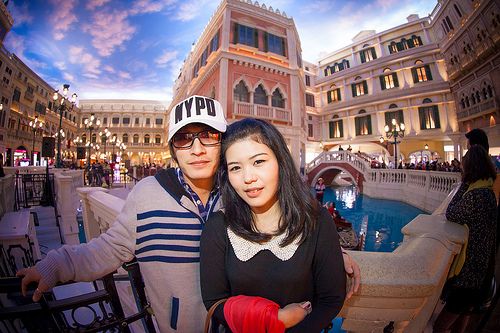<image>
Is there a cap on the head? No. The cap is not positioned on the head. They may be near each other, but the cap is not supported by or resting on top of the head. 